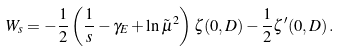Convert formula to latex. <formula><loc_0><loc_0><loc_500><loc_500>W _ { s } = - \frac { 1 } { 2 } \left ( \frac { 1 } { s } - \gamma _ { E } + \ln \tilde { \mu } ^ { 2 } \right ) \zeta ( 0 , D ) - \frac { 1 } { 2 } \zeta ^ { \prime } ( 0 , D ) \, .</formula> 